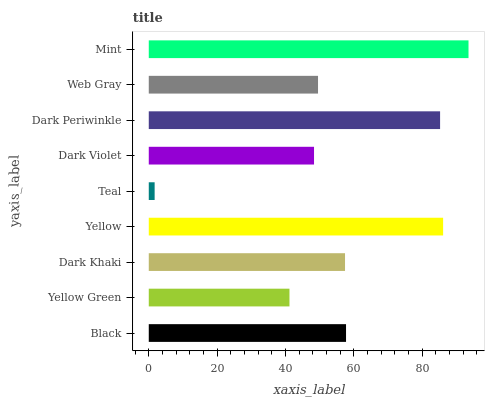Is Teal the minimum?
Answer yes or no. Yes. Is Mint the maximum?
Answer yes or no. Yes. Is Yellow Green the minimum?
Answer yes or no. No. Is Yellow Green the maximum?
Answer yes or no. No. Is Black greater than Yellow Green?
Answer yes or no. Yes. Is Yellow Green less than Black?
Answer yes or no. Yes. Is Yellow Green greater than Black?
Answer yes or no. No. Is Black less than Yellow Green?
Answer yes or no. No. Is Dark Khaki the high median?
Answer yes or no. Yes. Is Dark Khaki the low median?
Answer yes or no. Yes. Is Yellow the high median?
Answer yes or no. No. Is Web Gray the low median?
Answer yes or no. No. 